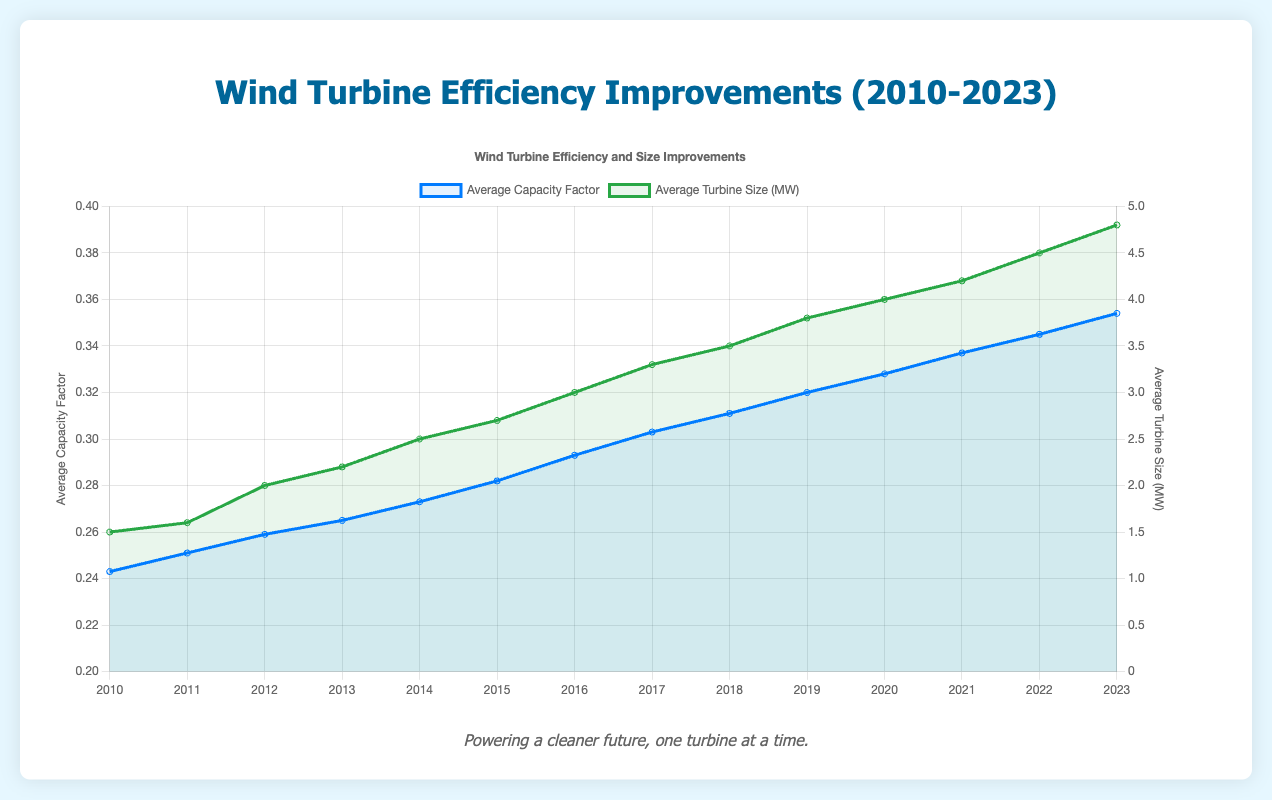What is the average improvement in capacity factor per year from 2010 to 2023? First, find the total increase in capacity factor from 2010 (0.243) to 2023 (0.354), which is 0.354 - 0.243 = 0.111. Then divide this by the number of years, which is 2023 - 2010 = 13 years. So the average improvement per year is 0.111 / 13.
Answer: 0.00854 Between which years did the average turbine size increase the most? To find this, calculate the year-over-year increase in average turbine size and compare. The increases are: 0.1 MW (2010 to 2011), 0.4 MW (2011 to 2012), 0.2 MW (2012 to 2013), 0.3 MW (2013 to 2014), 0.2 MW (2014 to 2015), 0.3 MW (2015 to 2016), 0.3 MW (2016 to 2017), 0.2 MW (2017 to 2018), 0.3 MW (2018 to 2019), 0.2 MW (2019 to 2020), 0.2 MW (2020 to 2021), 0.3 MW (2021 to 2022), and 0.3 MW (2022 to 2023). The largest increase is 0.4 MW from 2011 to 2012.
Answer: 2011 to 2012 Which year had the highest capacity factor and what was it? Look at the capacity factor values for each year and identify the highest one, which corresponds to 2023 with a value of 0.354.
Answer: 2023, 0.354 Compared to 2010, how much more efficient were wind turbines in 2023? Calculate the increase in capacity factor from 2010 (0.243) to 2023 (0.354). The difference is 0.354 - 0.243 = 0.111, showing the efficiency improvement.
Answer: 0.111 What was the technology used in 2015 and what innovation accompanied it? Refer to the entry for the year 2015, which lists "Enercon E-101" as the technology and "Permanent Magnet Generators" as the notable innovation.
Answer: Enercon E-101, Permanent Magnet Generators Which year saw the introduction of "Integrated Energy Storage"? Check the notable innovations year by year and match "Integrated Energy Storage" with its corresponding year, which is 2020.
Answer: 2020 How does the trend in average turbine size compare to the trend in capacity factor from 2010 to 2023? Observing the trends, both the average turbine size and the capacity factor exhibit an increasing trend from 2010 to 2023. However, while the capacity factor increases more gradually, the turbine size shows more pronounced jumps in specific years.
Answer: Both trends are increasing, but the turbine size shows more noticeable jumps Which year witnessed the smallest increase in capacity factor compared to the previous year? Calculate the year-over-year increase in capacity factor and find the smallest increment: 0.008 (2010 to 2011), 0.008 (2011 to 2012), 0.006 (2012 to 2013), 0.008 (2013 to 2014), 0.009 (2014 to 2015), 0.011 (2015 to 2016), 0.01 (2016 to 2017), 0.008 (2017 to 2018), 0.009 (2018 to 2019), 0.008 (2019 to 2020), 0.009 (2020 to 2021), 0.008 (2021 to 2022), 0.009 (2022 to 2023). The smallest was 0.006 from 2012 to 2013.
Answer: 2012 to 2013 